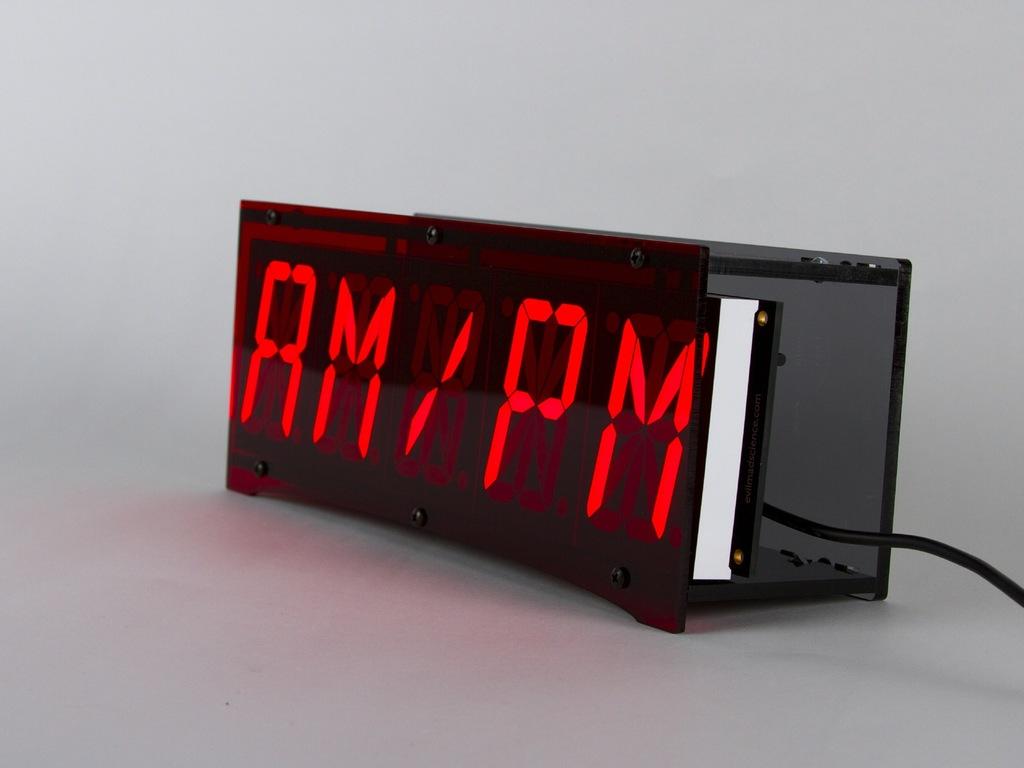What is on the clock?
Provide a short and direct response. Am/pm. 